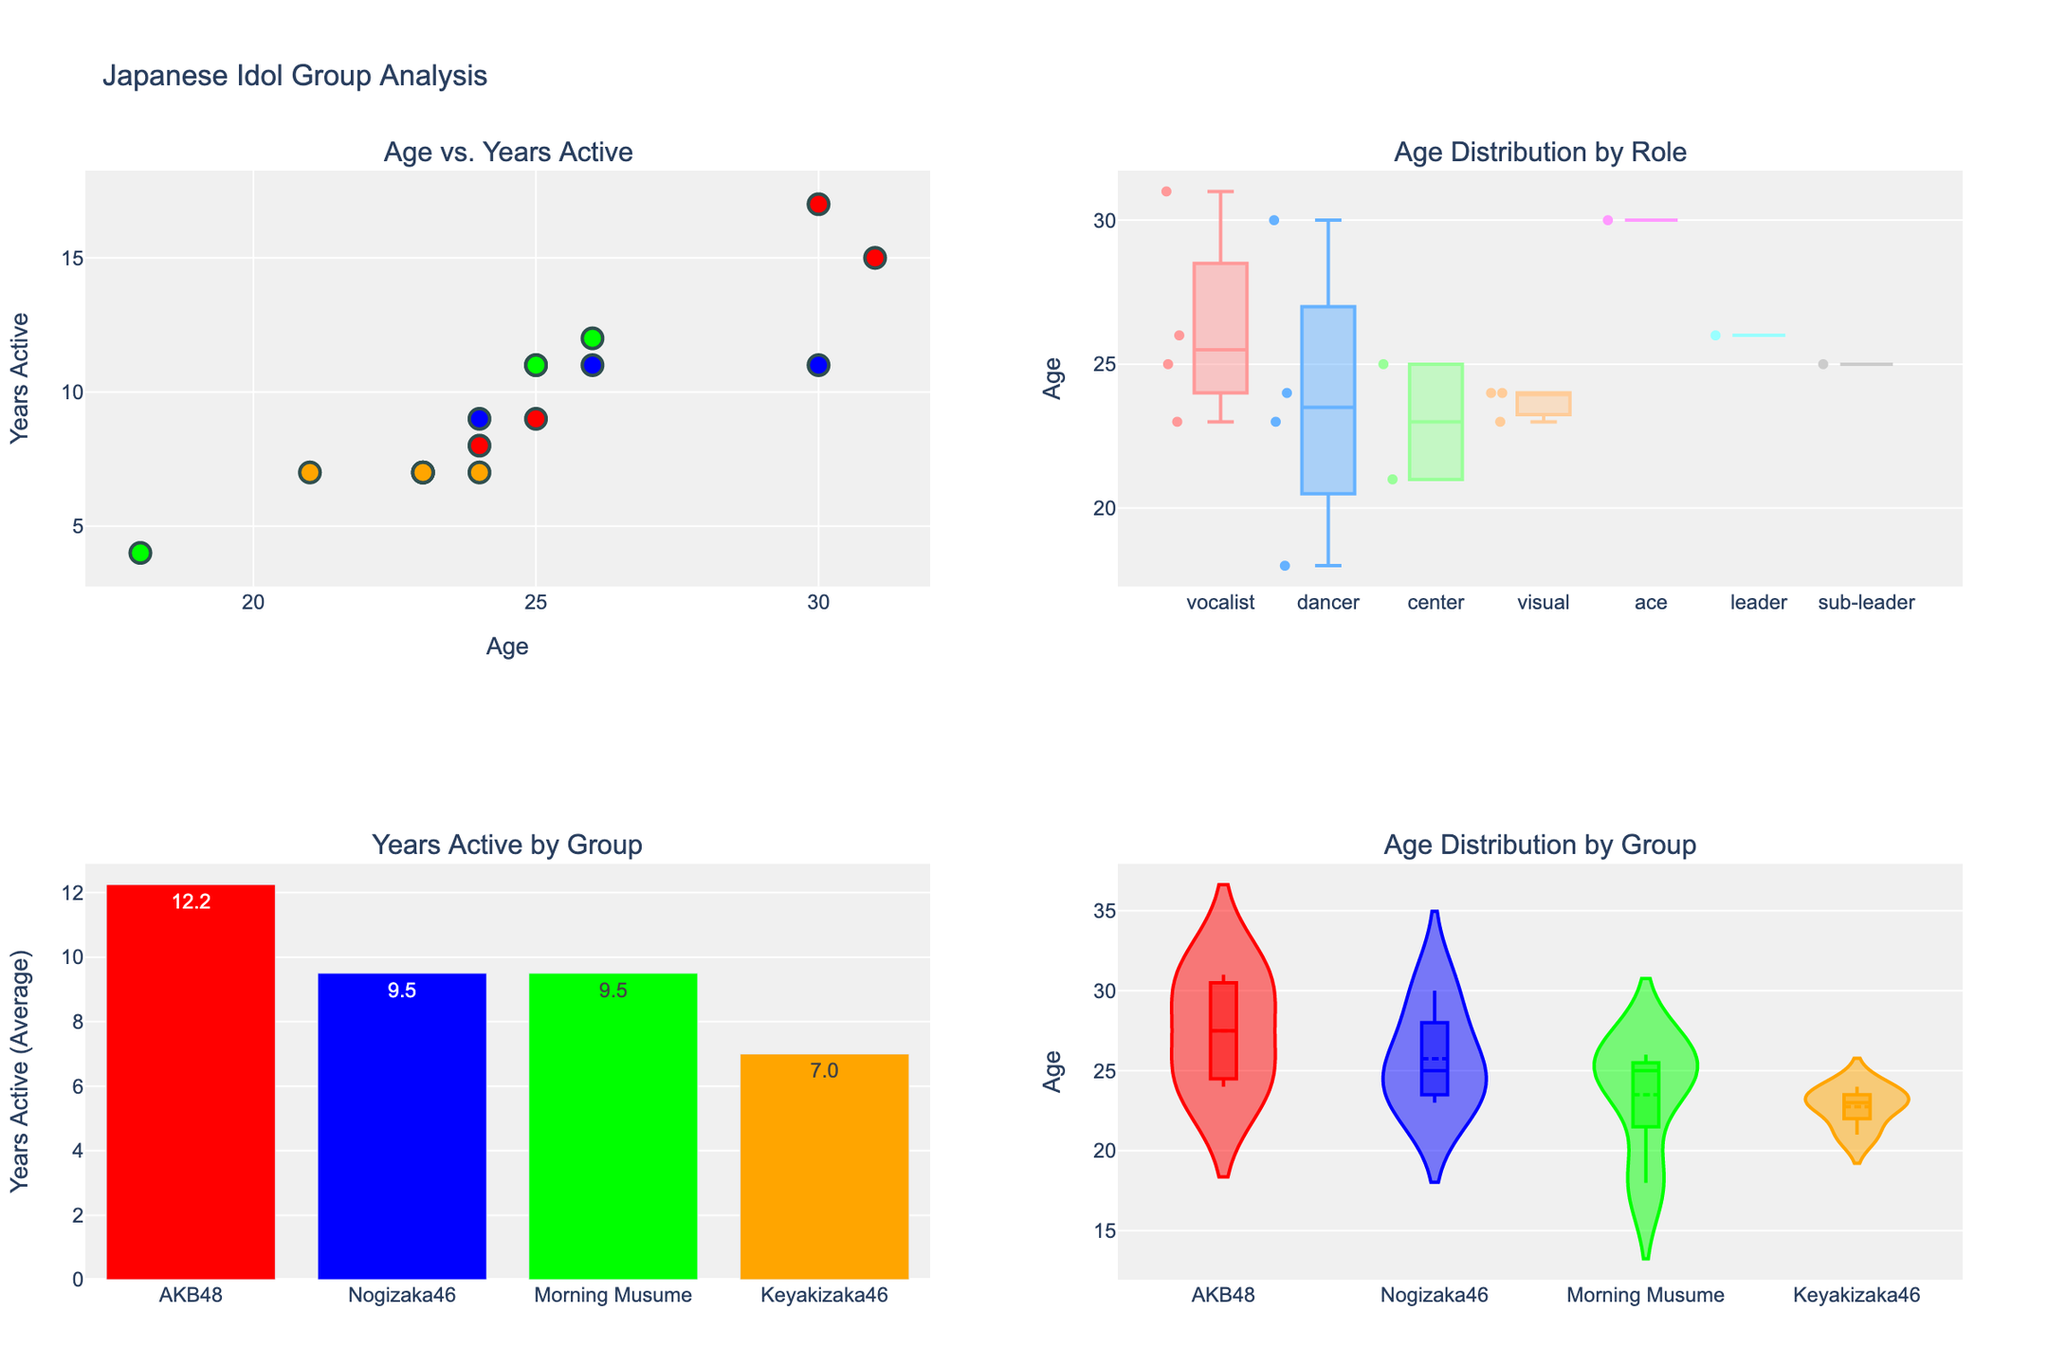What are the ages of the members represented in the 'Age vs. Years Active' scatter plot? To find the ages, look at the x-axis values of the scatter plot. The ages are the horizontal positions of the data points in the plot.
Answer: 18, 21, 23, 24, 25, 26, 30, 31 Which group has the oldest member and what is their role? By examining the scatter plot, identify the data point with the highest x-axis value and then use the hover information to determine the group and role. The oldest member is from AKB48, and the age is 31. Hovering over that point reveals the role as a vocalist.
Answer: AKB48, vocalist What is the range of ages for the 'visual' role in the 'Age Distribution by Role' box plot? Analyze the box plot for the 'visual' role, where the bottom and top of the box represent the lower quartile (Q1) and upper quartile (Q3), and the ends of the "whiskers" represent the minimum and maximum ages. The age values for 'visual' range from 23 to 24.
Answer: 23 to 24 Which idol group has the longest average years of activity according to the 'Years Active by Group' bar plot? Check the height of the bars in this plot. The tallest bar represents the group with the longest average years active. Nogizaka46 has the highest bar.
Answer: Nogizaka46 How do the ages of the members of Keyakizaka46 compare to those of Morning Musume? Look at the 'Age Distribution by Group' violin plot to compare the spread and central tendency of ages for both groups. The median age for Keyakizaka46 members is lower compared to Morning Musume members.
Answer: Keyakizaka46 members are generally younger Which role shows the widest range in age distribution? In the 'Age Distribution by Role' box plot, the role with the longest box (from the minimum to maximum data point) indicates the widest range. The 'vocalist' role shows the widest range.
Answer: Vocalist What is the age of the member with the fewest years active in the 'Age vs. Years Active' scatter plot? Identify the data point with the lowest y-axis value (indicating fewest years active) in the scatter plot and check its x-axis value for the age. This data point is at (18, 4).
Answer: 18 Which group has the most variability in age among its members according to the 'Age Distribution by Group' violin plot? Examine the width and spread of the violins in this plot. The group with the most spread along the y-axis has the most variability. Morning Musume's violin, which shows the widest spread, indicates the most variability.
Answer: Morning Musume What is the average age of the 'center' role members based on the 'Age Distribution by Role' box plot? For the 'center' role, identify the middle line in the box (median) and consider it along with the interquartile range for a rough estimate. The ages are closely concentrated around the median, 23 years for one member and 26 for another, making the average roughly 25 years.
Answer: 25 Which member has the most years active and what group are they from? Look at the scatter plot 'Age vs. Years Active' and identify the data point highest on the y-axis. Hovering over that data point shows it represents Minami Minegishi from AKB48 with 17 years active.
Answer: Minami Minegishi, AKB48 